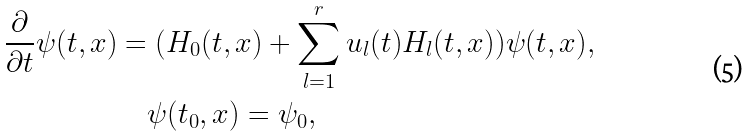Convert formula to latex. <formula><loc_0><loc_0><loc_500><loc_500>\frac { \partial } { \partial t } \psi ( t , x ) & = ( H _ { 0 } ( t , x ) + \sum _ { l = 1 } ^ { r } u _ { l } ( t ) H _ { l } ( t , x ) ) \psi ( t , x ) , \\ & \quad \psi ( t _ { 0 } , x ) = \psi _ { 0 } ,</formula> 